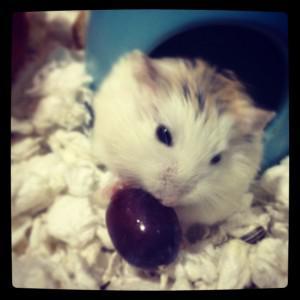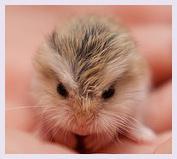The first image is the image on the left, the second image is the image on the right. For the images displayed, is the sentence "There are no more than two mice eating out of a tray/bowl." factually correct? Answer yes or no. No. The first image is the image on the left, the second image is the image on the right. Analyze the images presented: Is the assertion "There are no more than 2 hamsters in the image pair" valid? Answer yes or no. Yes. 